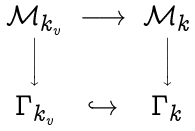<formula> <loc_0><loc_0><loc_500><loc_500>\begin{array} { c c c } { \mathcal { M } } _ { k _ { v } } & \longrightarrow & { \mathcal { M } } _ { k } \\ \Big \downarrow & & \Big \downarrow \\ \Gamma _ { k _ { v } } & \hookrightarrow & \Gamma _ { k } \end{array}</formula> 